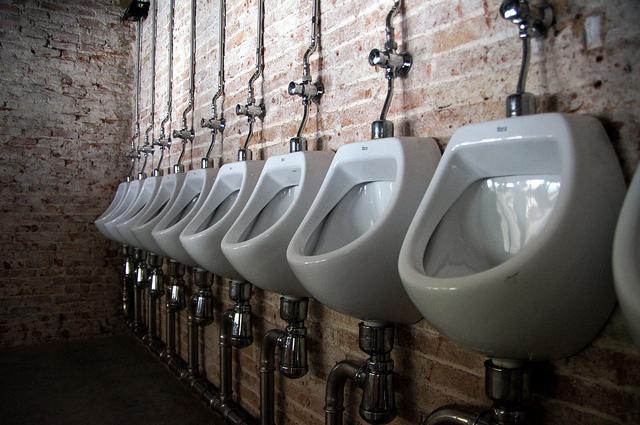How many urinals are there?
Concise answer only. 10. What is on the wall where the urinals are attached to?
Quick response, please. Brick. What is the wall made of?
Write a very short answer. Brick. 